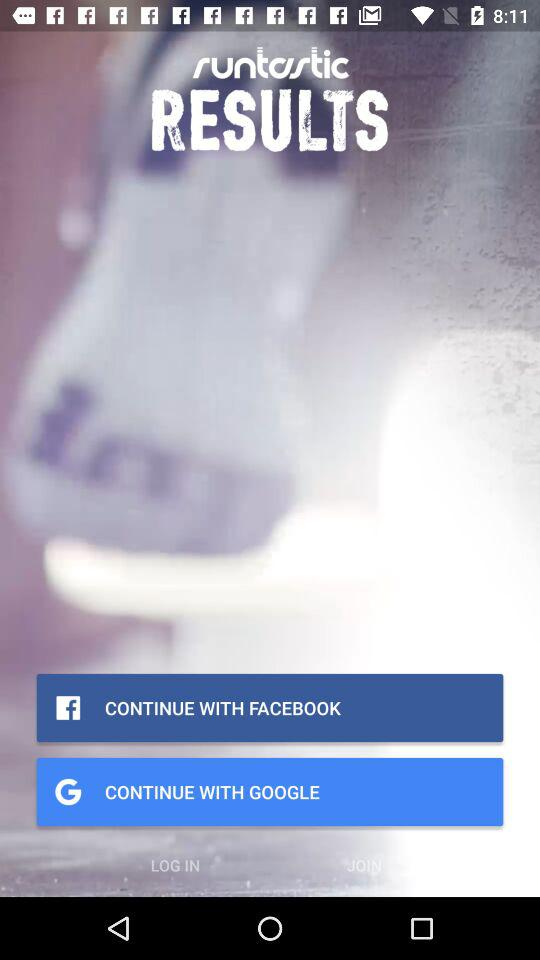What is the duration of the training plan? The duration is 12 weeks. 